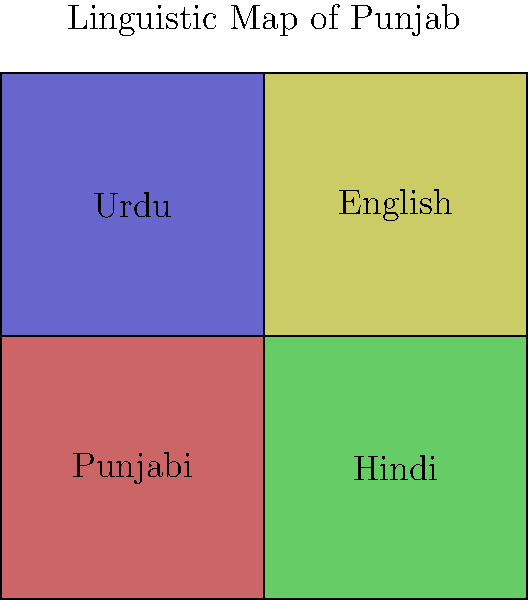Based on the color-coded linguistic map of Punjab, which language appears to be predominantly spoken in the southwestern region of the state? To answer this question, we need to analyze the color-coded map of Punjab's linguistic diversity:

1. The map is divided into four quadrants, each representing a different language spoken in Punjab.
2. Each quadrant is filled with a distinct color, representing a specific language:
   - Red (top-left): Punjabi
   - Green (top-right): Hindi
   - Blue (bottom-left): Urdu
   - Yellow (bottom-right): English
3. The southwestern region of Punjab would correspond to the bottom-left quadrant of the map.
4. The bottom-left quadrant is colored blue and labeled "Urdu".

Therefore, according to this simplified linguistic map, Urdu appears to be the predominantly spoken language in the southwestern region of Punjab.
Answer: Urdu 